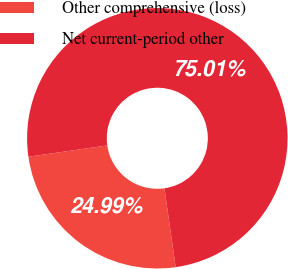Convert chart. <chart><loc_0><loc_0><loc_500><loc_500><pie_chart><fcel>Other comprehensive (loss)<fcel>Net current-period other<nl><fcel>24.99%<fcel>75.01%<nl></chart> 